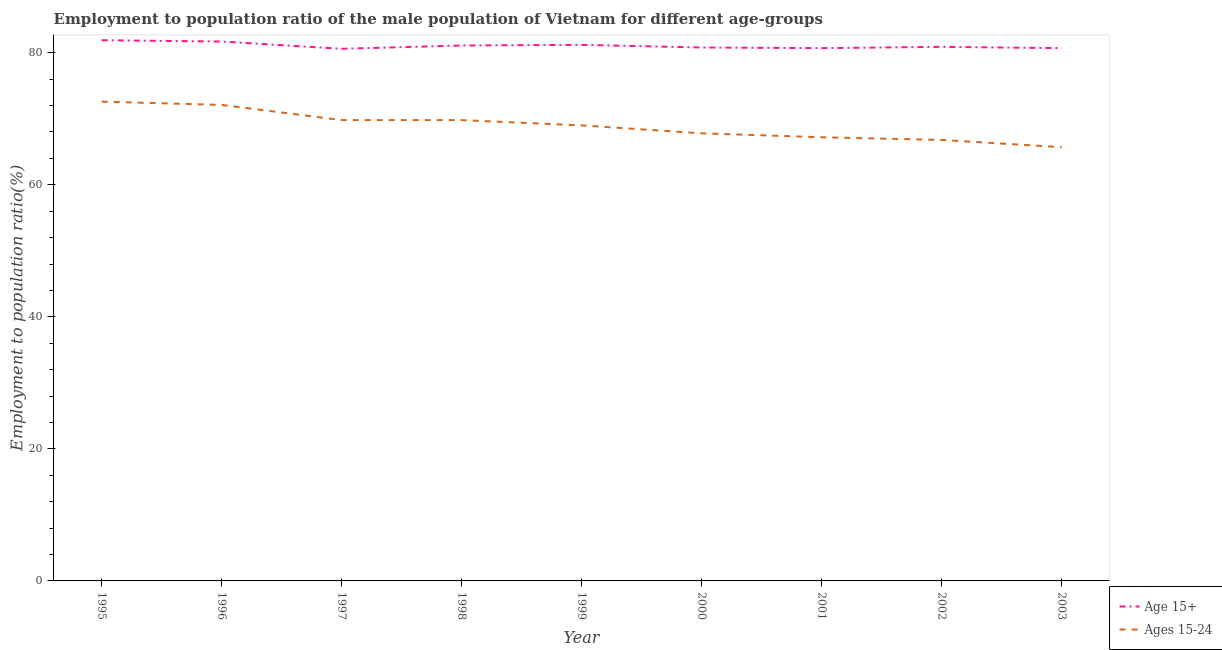Is the number of lines equal to the number of legend labels?
Your answer should be compact. Yes. What is the employment to population ratio(age 15+) in 2001?
Make the answer very short. 80.7. Across all years, what is the maximum employment to population ratio(age 15-24)?
Offer a terse response. 72.6. Across all years, what is the minimum employment to population ratio(age 15+)?
Make the answer very short. 80.6. What is the total employment to population ratio(age 15-24) in the graph?
Offer a very short reply. 620.8. What is the difference between the employment to population ratio(age 15-24) in 1997 and that in 2003?
Your answer should be compact. 4.1. What is the difference between the employment to population ratio(age 15+) in 1998 and the employment to population ratio(age 15-24) in 2000?
Your answer should be very brief. 13.3. What is the average employment to population ratio(age 15-24) per year?
Offer a very short reply. 68.98. In the year 1997, what is the difference between the employment to population ratio(age 15-24) and employment to population ratio(age 15+)?
Provide a short and direct response. -10.8. In how many years, is the employment to population ratio(age 15-24) greater than 44 %?
Keep it short and to the point. 9. What is the ratio of the employment to population ratio(age 15+) in 1997 to that in 1999?
Your answer should be very brief. 0.99. Is the employment to population ratio(age 15+) in 1999 less than that in 2000?
Offer a very short reply. No. What is the difference between the highest and the second highest employment to population ratio(age 15+)?
Your response must be concise. 0.2. What is the difference between the highest and the lowest employment to population ratio(age 15-24)?
Make the answer very short. 6.9. In how many years, is the employment to population ratio(age 15-24) greater than the average employment to population ratio(age 15-24) taken over all years?
Provide a short and direct response. 5. Is the sum of the employment to population ratio(age 15+) in 1996 and 1998 greater than the maximum employment to population ratio(age 15-24) across all years?
Provide a short and direct response. Yes. Does the employment to population ratio(age 15-24) monotonically increase over the years?
Give a very brief answer. No. Is the employment to population ratio(age 15+) strictly less than the employment to population ratio(age 15-24) over the years?
Offer a terse response. No. How are the legend labels stacked?
Offer a very short reply. Vertical. What is the title of the graph?
Your response must be concise. Employment to population ratio of the male population of Vietnam for different age-groups. Does "Infant" appear as one of the legend labels in the graph?
Give a very brief answer. No. What is the label or title of the X-axis?
Give a very brief answer. Year. What is the Employment to population ratio(%) of Age 15+ in 1995?
Give a very brief answer. 81.9. What is the Employment to population ratio(%) of Ages 15-24 in 1995?
Make the answer very short. 72.6. What is the Employment to population ratio(%) of Age 15+ in 1996?
Your answer should be compact. 81.7. What is the Employment to population ratio(%) in Ages 15-24 in 1996?
Provide a short and direct response. 72.1. What is the Employment to population ratio(%) of Age 15+ in 1997?
Give a very brief answer. 80.6. What is the Employment to population ratio(%) of Ages 15-24 in 1997?
Keep it short and to the point. 69.8. What is the Employment to population ratio(%) of Age 15+ in 1998?
Offer a very short reply. 81.1. What is the Employment to population ratio(%) of Ages 15-24 in 1998?
Offer a terse response. 69.8. What is the Employment to population ratio(%) in Age 15+ in 1999?
Provide a succinct answer. 81.2. What is the Employment to population ratio(%) in Age 15+ in 2000?
Your answer should be compact. 80.8. What is the Employment to population ratio(%) in Ages 15-24 in 2000?
Make the answer very short. 67.8. What is the Employment to population ratio(%) in Age 15+ in 2001?
Your response must be concise. 80.7. What is the Employment to population ratio(%) of Ages 15-24 in 2001?
Offer a terse response. 67.2. What is the Employment to population ratio(%) in Age 15+ in 2002?
Keep it short and to the point. 80.9. What is the Employment to population ratio(%) in Ages 15-24 in 2002?
Offer a terse response. 66.8. What is the Employment to population ratio(%) in Age 15+ in 2003?
Give a very brief answer. 80.7. What is the Employment to population ratio(%) of Ages 15-24 in 2003?
Make the answer very short. 65.7. Across all years, what is the maximum Employment to population ratio(%) of Age 15+?
Make the answer very short. 81.9. Across all years, what is the maximum Employment to population ratio(%) of Ages 15-24?
Keep it short and to the point. 72.6. Across all years, what is the minimum Employment to population ratio(%) of Age 15+?
Your answer should be compact. 80.6. Across all years, what is the minimum Employment to population ratio(%) in Ages 15-24?
Ensure brevity in your answer.  65.7. What is the total Employment to population ratio(%) of Age 15+ in the graph?
Provide a succinct answer. 729.6. What is the total Employment to population ratio(%) of Ages 15-24 in the graph?
Your response must be concise. 620.8. What is the difference between the Employment to population ratio(%) in Ages 15-24 in 1995 and that in 1996?
Provide a succinct answer. 0.5. What is the difference between the Employment to population ratio(%) in Ages 15-24 in 1995 and that in 1997?
Provide a short and direct response. 2.8. What is the difference between the Employment to population ratio(%) of Age 15+ in 1995 and that in 1998?
Make the answer very short. 0.8. What is the difference between the Employment to population ratio(%) of Age 15+ in 1995 and that in 1999?
Your response must be concise. 0.7. What is the difference between the Employment to population ratio(%) of Ages 15-24 in 1995 and that in 2000?
Your response must be concise. 4.8. What is the difference between the Employment to population ratio(%) of Ages 15-24 in 1995 and that in 2003?
Offer a terse response. 6.9. What is the difference between the Employment to population ratio(%) of Age 15+ in 1996 and that in 1999?
Offer a very short reply. 0.5. What is the difference between the Employment to population ratio(%) of Ages 15-24 in 1996 and that in 1999?
Ensure brevity in your answer.  3.1. What is the difference between the Employment to population ratio(%) in Age 15+ in 1996 and that in 2000?
Provide a succinct answer. 0.9. What is the difference between the Employment to population ratio(%) of Age 15+ in 1996 and that in 2001?
Give a very brief answer. 1. What is the difference between the Employment to population ratio(%) of Ages 15-24 in 1996 and that in 2001?
Offer a terse response. 4.9. What is the difference between the Employment to population ratio(%) in Age 15+ in 1996 and that in 2003?
Your answer should be very brief. 1. What is the difference between the Employment to population ratio(%) of Ages 15-24 in 1996 and that in 2003?
Provide a succinct answer. 6.4. What is the difference between the Employment to population ratio(%) of Ages 15-24 in 1997 and that in 1998?
Offer a very short reply. 0. What is the difference between the Employment to population ratio(%) in Age 15+ in 1997 and that in 2000?
Give a very brief answer. -0.2. What is the difference between the Employment to population ratio(%) of Age 15+ in 1997 and that in 2002?
Your answer should be compact. -0.3. What is the difference between the Employment to population ratio(%) in Ages 15-24 in 1997 and that in 2002?
Provide a short and direct response. 3. What is the difference between the Employment to population ratio(%) of Age 15+ in 1997 and that in 2003?
Offer a terse response. -0.1. What is the difference between the Employment to population ratio(%) in Age 15+ in 1998 and that in 1999?
Make the answer very short. -0.1. What is the difference between the Employment to population ratio(%) of Age 15+ in 1998 and that in 2000?
Your answer should be very brief. 0.3. What is the difference between the Employment to population ratio(%) in Ages 15-24 in 1998 and that in 2000?
Offer a very short reply. 2. What is the difference between the Employment to population ratio(%) of Age 15+ in 1998 and that in 2002?
Give a very brief answer. 0.2. What is the difference between the Employment to population ratio(%) of Ages 15-24 in 1998 and that in 2003?
Keep it short and to the point. 4.1. What is the difference between the Employment to population ratio(%) of Age 15+ in 1999 and that in 2000?
Offer a terse response. 0.4. What is the difference between the Employment to population ratio(%) in Ages 15-24 in 1999 and that in 2003?
Your answer should be compact. 3.3. What is the difference between the Employment to population ratio(%) in Ages 15-24 in 2000 and that in 2001?
Offer a very short reply. 0.6. What is the difference between the Employment to population ratio(%) of Ages 15-24 in 2000 and that in 2003?
Your answer should be very brief. 2.1. What is the difference between the Employment to population ratio(%) of Ages 15-24 in 2001 and that in 2002?
Keep it short and to the point. 0.4. What is the difference between the Employment to population ratio(%) of Age 15+ in 2001 and that in 2003?
Provide a short and direct response. 0. What is the difference between the Employment to population ratio(%) in Ages 15-24 in 2002 and that in 2003?
Provide a short and direct response. 1.1. What is the difference between the Employment to population ratio(%) in Age 15+ in 1995 and the Employment to population ratio(%) in Ages 15-24 in 1997?
Make the answer very short. 12.1. What is the difference between the Employment to population ratio(%) in Age 15+ in 1996 and the Employment to population ratio(%) in Ages 15-24 in 1997?
Ensure brevity in your answer.  11.9. What is the difference between the Employment to population ratio(%) of Age 15+ in 1996 and the Employment to population ratio(%) of Ages 15-24 in 1999?
Your answer should be compact. 12.7. What is the difference between the Employment to population ratio(%) of Age 15+ in 1996 and the Employment to population ratio(%) of Ages 15-24 in 2001?
Your response must be concise. 14.5. What is the difference between the Employment to population ratio(%) of Age 15+ in 1997 and the Employment to population ratio(%) of Ages 15-24 in 1998?
Your response must be concise. 10.8. What is the difference between the Employment to population ratio(%) of Age 15+ in 1997 and the Employment to population ratio(%) of Ages 15-24 in 1999?
Offer a terse response. 11.6. What is the difference between the Employment to population ratio(%) of Age 15+ in 1997 and the Employment to population ratio(%) of Ages 15-24 in 2001?
Your answer should be very brief. 13.4. What is the difference between the Employment to population ratio(%) in Age 15+ in 1997 and the Employment to population ratio(%) in Ages 15-24 in 2003?
Ensure brevity in your answer.  14.9. What is the difference between the Employment to population ratio(%) in Age 15+ in 1998 and the Employment to population ratio(%) in Ages 15-24 in 1999?
Provide a succinct answer. 12.1. What is the difference between the Employment to population ratio(%) of Age 15+ in 1998 and the Employment to population ratio(%) of Ages 15-24 in 2000?
Offer a very short reply. 13.3. What is the difference between the Employment to population ratio(%) of Age 15+ in 1998 and the Employment to population ratio(%) of Ages 15-24 in 2001?
Your response must be concise. 13.9. What is the difference between the Employment to population ratio(%) of Age 15+ in 1998 and the Employment to population ratio(%) of Ages 15-24 in 2002?
Provide a short and direct response. 14.3. What is the difference between the Employment to population ratio(%) in Age 15+ in 1998 and the Employment to population ratio(%) in Ages 15-24 in 2003?
Make the answer very short. 15.4. What is the difference between the Employment to population ratio(%) of Age 15+ in 1999 and the Employment to population ratio(%) of Ages 15-24 in 2000?
Keep it short and to the point. 13.4. What is the difference between the Employment to population ratio(%) in Age 15+ in 1999 and the Employment to population ratio(%) in Ages 15-24 in 2002?
Your answer should be compact. 14.4. What is the difference between the Employment to population ratio(%) in Age 15+ in 1999 and the Employment to population ratio(%) in Ages 15-24 in 2003?
Make the answer very short. 15.5. What is the difference between the Employment to population ratio(%) in Age 15+ in 2000 and the Employment to population ratio(%) in Ages 15-24 in 2001?
Provide a succinct answer. 13.6. What is the difference between the Employment to population ratio(%) of Age 15+ in 2000 and the Employment to population ratio(%) of Ages 15-24 in 2002?
Provide a succinct answer. 14. What is the difference between the Employment to population ratio(%) of Age 15+ in 2000 and the Employment to population ratio(%) of Ages 15-24 in 2003?
Make the answer very short. 15.1. What is the difference between the Employment to population ratio(%) of Age 15+ in 2001 and the Employment to population ratio(%) of Ages 15-24 in 2002?
Make the answer very short. 13.9. What is the difference between the Employment to population ratio(%) of Age 15+ in 2001 and the Employment to population ratio(%) of Ages 15-24 in 2003?
Offer a very short reply. 15. What is the average Employment to population ratio(%) of Age 15+ per year?
Your answer should be very brief. 81.07. What is the average Employment to population ratio(%) in Ages 15-24 per year?
Your answer should be compact. 68.98. In the year 1996, what is the difference between the Employment to population ratio(%) of Age 15+ and Employment to population ratio(%) of Ages 15-24?
Your answer should be compact. 9.6. In the year 1997, what is the difference between the Employment to population ratio(%) in Age 15+ and Employment to population ratio(%) in Ages 15-24?
Ensure brevity in your answer.  10.8. In the year 1999, what is the difference between the Employment to population ratio(%) of Age 15+ and Employment to population ratio(%) of Ages 15-24?
Offer a terse response. 12.2. In the year 2000, what is the difference between the Employment to population ratio(%) in Age 15+ and Employment to population ratio(%) in Ages 15-24?
Provide a succinct answer. 13. In the year 2001, what is the difference between the Employment to population ratio(%) in Age 15+ and Employment to population ratio(%) in Ages 15-24?
Your answer should be compact. 13.5. In the year 2002, what is the difference between the Employment to population ratio(%) in Age 15+ and Employment to population ratio(%) in Ages 15-24?
Make the answer very short. 14.1. In the year 2003, what is the difference between the Employment to population ratio(%) in Age 15+ and Employment to population ratio(%) in Ages 15-24?
Make the answer very short. 15. What is the ratio of the Employment to population ratio(%) in Age 15+ in 1995 to that in 1996?
Give a very brief answer. 1. What is the ratio of the Employment to population ratio(%) of Ages 15-24 in 1995 to that in 1996?
Your response must be concise. 1.01. What is the ratio of the Employment to population ratio(%) in Age 15+ in 1995 to that in 1997?
Offer a terse response. 1.02. What is the ratio of the Employment to population ratio(%) of Ages 15-24 in 1995 to that in 1997?
Offer a terse response. 1.04. What is the ratio of the Employment to population ratio(%) in Age 15+ in 1995 to that in 1998?
Offer a very short reply. 1.01. What is the ratio of the Employment to population ratio(%) in Ages 15-24 in 1995 to that in 1998?
Offer a very short reply. 1.04. What is the ratio of the Employment to population ratio(%) of Age 15+ in 1995 to that in 1999?
Offer a terse response. 1.01. What is the ratio of the Employment to population ratio(%) of Ages 15-24 in 1995 to that in 1999?
Offer a very short reply. 1.05. What is the ratio of the Employment to population ratio(%) of Age 15+ in 1995 to that in 2000?
Give a very brief answer. 1.01. What is the ratio of the Employment to population ratio(%) of Ages 15-24 in 1995 to that in 2000?
Offer a very short reply. 1.07. What is the ratio of the Employment to population ratio(%) of Age 15+ in 1995 to that in 2001?
Ensure brevity in your answer.  1.01. What is the ratio of the Employment to population ratio(%) of Ages 15-24 in 1995 to that in 2001?
Provide a short and direct response. 1.08. What is the ratio of the Employment to population ratio(%) of Age 15+ in 1995 to that in 2002?
Offer a terse response. 1.01. What is the ratio of the Employment to population ratio(%) of Ages 15-24 in 1995 to that in 2002?
Your answer should be compact. 1.09. What is the ratio of the Employment to population ratio(%) in Age 15+ in 1995 to that in 2003?
Provide a short and direct response. 1.01. What is the ratio of the Employment to population ratio(%) of Ages 15-24 in 1995 to that in 2003?
Your answer should be compact. 1.1. What is the ratio of the Employment to population ratio(%) in Age 15+ in 1996 to that in 1997?
Ensure brevity in your answer.  1.01. What is the ratio of the Employment to population ratio(%) of Ages 15-24 in 1996 to that in 1997?
Offer a terse response. 1.03. What is the ratio of the Employment to population ratio(%) of Age 15+ in 1996 to that in 1998?
Keep it short and to the point. 1.01. What is the ratio of the Employment to population ratio(%) in Ages 15-24 in 1996 to that in 1998?
Give a very brief answer. 1.03. What is the ratio of the Employment to population ratio(%) in Ages 15-24 in 1996 to that in 1999?
Your answer should be compact. 1.04. What is the ratio of the Employment to population ratio(%) in Age 15+ in 1996 to that in 2000?
Provide a succinct answer. 1.01. What is the ratio of the Employment to population ratio(%) in Ages 15-24 in 1996 to that in 2000?
Provide a short and direct response. 1.06. What is the ratio of the Employment to population ratio(%) of Age 15+ in 1996 to that in 2001?
Make the answer very short. 1.01. What is the ratio of the Employment to population ratio(%) of Ages 15-24 in 1996 to that in 2001?
Provide a succinct answer. 1.07. What is the ratio of the Employment to population ratio(%) in Age 15+ in 1996 to that in 2002?
Make the answer very short. 1.01. What is the ratio of the Employment to population ratio(%) in Ages 15-24 in 1996 to that in 2002?
Your answer should be very brief. 1.08. What is the ratio of the Employment to population ratio(%) in Age 15+ in 1996 to that in 2003?
Keep it short and to the point. 1.01. What is the ratio of the Employment to population ratio(%) of Ages 15-24 in 1996 to that in 2003?
Make the answer very short. 1.1. What is the ratio of the Employment to population ratio(%) of Age 15+ in 1997 to that in 1998?
Keep it short and to the point. 0.99. What is the ratio of the Employment to population ratio(%) of Age 15+ in 1997 to that in 1999?
Ensure brevity in your answer.  0.99. What is the ratio of the Employment to population ratio(%) in Ages 15-24 in 1997 to that in 1999?
Make the answer very short. 1.01. What is the ratio of the Employment to population ratio(%) in Age 15+ in 1997 to that in 2000?
Provide a short and direct response. 1. What is the ratio of the Employment to population ratio(%) in Ages 15-24 in 1997 to that in 2000?
Offer a terse response. 1.03. What is the ratio of the Employment to population ratio(%) of Age 15+ in 1997 to that in 2001?
Keep it short and to the point. 1. What is the ratio of the Employment to population ratio(%) of Ages 15-24 in 1997 to that in 2001?
Give a very brief answer. 1.04. What is the ratio of the Employment to population ratio(%) of Age 15+ in 1997 to that in 2002?
Make the answer very short. 1. What is the ratio of the Employment to population ratio(%) in Ages 15-24 in 1997 to that in 2002?
Offer a very short reply. 1.04. What is the ratio of the Employment to population ratio(%) of Age 15+ in 1997 to that in 2003?
Offer a terse response. 1. What is the ratio of the Employment to population ratio(%) in Ages 15-24 in 1997 to that in 2003?
Provide a short and direct response. 1.06. What is the ratio of the Employment to population ratio(%) of Ages 15-24 in 1998 to that in 1999?
Offer a very short reply. 1.01. What is the ratio of the Employment to population ratio(%) in Age 15+ in 1998 to that in 2000?
Your response must be concise. 1. What is the ratio of the Employment to population ratio(%) of Ages 15-24 in 1998 to that in 2000?
Keep it short and to the point. 1.03. What is the ratio of the Employment to population ratio(%) in Ages 15-24 in 1998 to that in 2001?
Provide a succinct answer. 1.04. What is the ratio of the Employment to population ratio(%) of Ages 15-24 in 1998 to that in 2002?
Provide a short and direct response. 1.04. What is the ratio of the Employment to population ratio(%) of Age 15+ in 1998 to that in 2003?
Your answer should be very brief. 1. What is the ratio of the Employment to population ratio(%) of Ages 15-24 in 1998 to that in 2003?
Keep it short and to the point. 1.06. What is the ratio of the Employment to population ratio(%) in Age 15+ in 1999 to that in 2000?
Your answer should be very brief. 1. What is the ratio of the Employment to population ratio(%) in Ages 15-24 in 1999 to that in 2000?
Ensure brevity in your answer.  1.02. What is the ratio of the Employment to population ratio(%) in Age 15+ in 1999 to that in 2001?
Provide a succinct answer. 1.01. What is the ratio of the Employment to population ratio(%) in Ages 15-24 in 1999 to that in 2001?
Make the answer very short. 1.03. What is the ratio of the Employment to population ratio(%) in Ages 15-24 in 1999 to that in 2002?
Make the answer very short. 1.03. What is the ratio of the Employment to population ratio(%) in Age 15+ in 1999 to that in 2003?
Your answer should be very brief. 1.01. What is the ratio of the Employment to population ratio(%) of Ages 15-24 in 1999 to that in 2003?
Make the answer very short. 1.05. What is the ratio of the Employment to population ratio(%) in Ages 15-24 in 2000 to that in 2001?
Give a very brief answer. 1.01. What is the ratio of the Employment to population ratio(%) in Age 15+ in 2000 to that in 2003?
Make the answer very short. 1. What is the ratio of the Employment to population ratio(%) of Ages 15-24 in 2000 to that in 2003?
Offer a very short reply. 1.03. What is the ratio of the Employment to population ratio(%) of Ages 15-24 in 2001 to that in 2003?
Make the answer very short. 1.02. What is the ratio of the Employment to population ratio(%) in Age 15+ in 2002 to that in 2003?
Make the answer very short. 1. What is the ratio of the Employment to population ratio(%) of Ages 15-24 in 2002 to that in 2003?
Give a very brief answer. 1.02. 